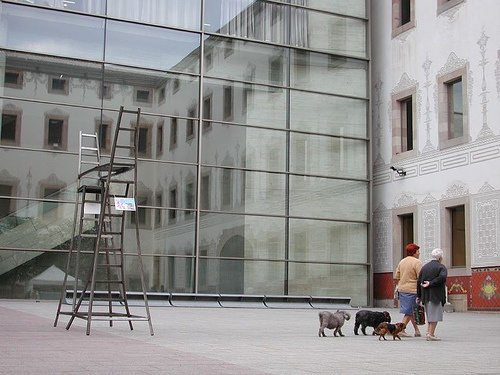Describe the objects in this image and their specific colors. I can see people in gray, black, and darkgray tones, people in gray and tan tones, dog in gray, black, and darkgray tones, dog in gray, darkgray, and black tones, and dog in gray, black, and maroon tones in this image. 